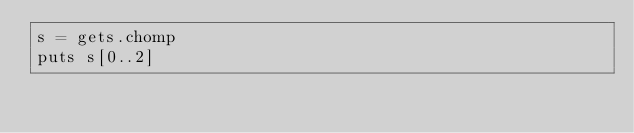<code> <loc_0><loc_0><loc_500><loc_500><_Ruby_>s = gets.chomp
puts s[0..2]</code> 